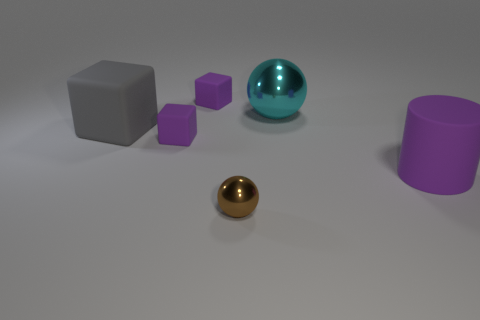There is a small rubber thing that is behind the block that is in front of the big gray thing; what is its shape?
Give a very brief answer. Cube. Does the small brown object have the same shape as the metallic object behind the purple cylinder?
Offer a terse response. Yes. What number of purple rubber objects are to the left of the metal object that is behind the rubber cylinder?
Your response must be concise. 2. How many gray things are either small metallic spheres or big cubes?
Keep it short and to the point. 1. Is there anything else that has the same color as the big ball?
Offer a very short reply. No. The metallic object in front of the purple object right of the large metallic object is what color?
Provide a short and direct response. Brown. Are there fewer large cyan metal balls that are in front of the big gray thing than large cylinders left of the big cyan thing?
Ensure brevity in your answer.  No. What number of things are objects left of the small metallic ball or small things?
Provide a succinct answer. 4. Does the purple rubber thing right of the brown sphere have the same size as the tiny metal ball?
Your answer should be compact. No. Are there fewer large blocks that are right of the small metallic ball than small gray shiny things?
Your response must be concise. No. 